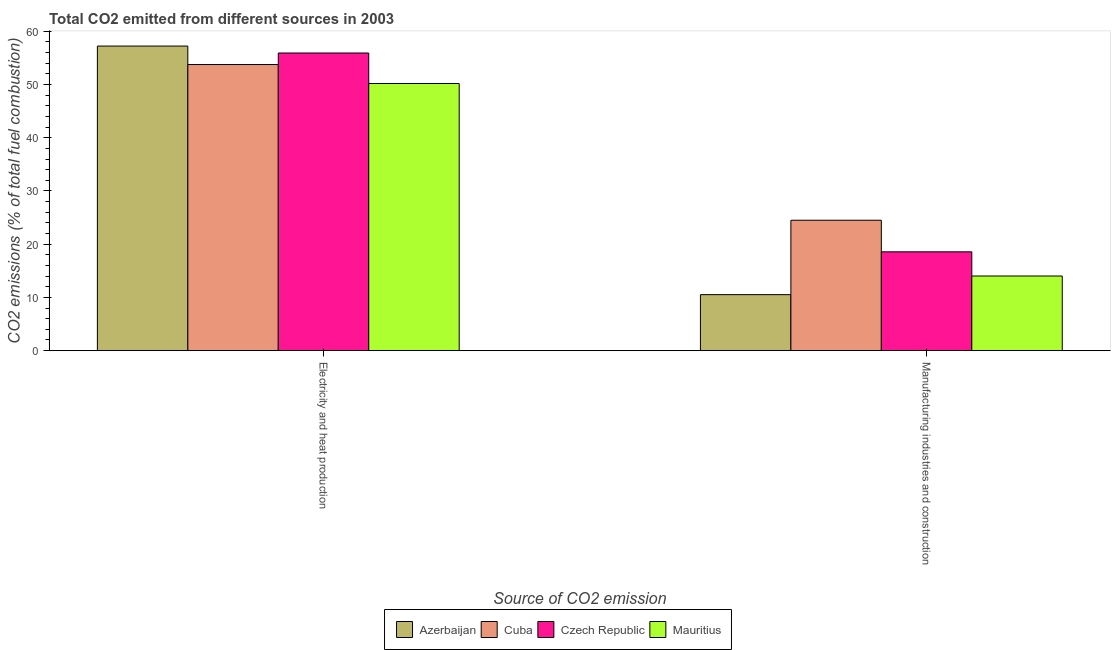Are the number of bars per tick equal to the number of legend labels?
Give a very brief answer. Yes. Are the number of bars on each tick of the X-axis equal?
Your answer should be compact. Yes. What is the label of the 1st group of bars from the left?
Your answer should be very brief. Electricity and heat production. What is the co2 emissions due to electricity and heat production in Azerbaijan?
Your response must be concise. 57.22. Across all countries, what is the maximum co2 emissions due to electricity and heat production?
Provide a short and direct response. 57.22. Across all countries, what is the minimum co2 emissions due to manufacturing industries?
Provide a succinct answer. 10.52. In which country was the co2 emissions due to manufacturing industries maximum?
Give a very brief answer. Cuba. In which country was the co2 emissions due to electricity and heat production minimum?
Give a very brief answer. Mauritius. What is the total co2 emissions due to manufacturing industries in the graph?
Offer a terse response. 67.6. What is the difference between the co2 emissions due to electricity and heat production in Azerbaijan and that in Mauritius?
Ensure brevity in your answer.  7.03. What is the difference between the co2 emissions due to manufacturing industries in Cuba and the co2 emissions due to electricity and heat production in Azerbaijan?
Make the answer very short. -32.72. What is the average co2 emissions due to electricity and heat production per country?
Provide a short and direct response. 54.27. What is the difference between the co2 emissions due to manufacturing industries and co2 emissions due to electricity and heat production in Czech Republic?
Keep it short and to the point. -37.35. In how many countries, is the co2 emissions due to manufacturing industries greater than 50 %?
Offer a terse response. 0. What is the ratio of the co2 emissions due to manufacturing industries in Cuba to that in Mauritius?
Your answer should be very brief. 1.75. In how many countries, is the co2 emissions due to electricity and heat production greater than the average co2 emissions due to electricity and heat production taken over all countries?
Keep it short and to the point. 2. What does the 2nd bar from the left in Manufacturing industries and construction represents?
Offer a terse response. Cuba. What does the 1st bar from the right in Manufacturing industries and construction represents?
Make the answer very short. Mauritius. How many bars are there?
Give a very brief answer. 8. How many countries are there in the graph?
Your answer should be compact. 4. What is the difference between two consecutive major ticks on the Y-axis?
Keep it short and to the point. 10. Are the values on the major ticks of Y-axis written in scientific E-notation?
Offer a terse response. No. Where does the legend appear in the graph?
Your answer should be compact. Bottom center. What is the title of the graph?
Provide a short and direct response. Total CO2 emitted from different sources in 2003. Does "Greece" appear as one of the legend labels in the graph?
Provide a short and direct response. No. What is the label or title of the X-axis?
Provide a succinct answer. Source of CO2 emission. What is the label or title of the Y-axis?
Provide a short and direct response. CO2 emissions (% of total fuel combustion). What is the CO2 emissions (% of total fuel combustion) in Azerbaijan in Electricity and heat production?
Give a very brief answer. 57.22. What is the CO2 emissions (% of total fuel combustion) in Cuba in Electricity and heat production?
Give a very brief answer. 53.75. What is the CO2 emissions (% of total fuel combustion) in Czech Republic in Electricity and heat production?
Make the answer very short. 55.91. What is the CO2 emissions (% of total fuel combustion) of Mauritius in Electricity and heat production?
Your answer should be very brief. 50.18. What is the CO2 emissions (% of total fuel combustion) in Azerbaijan in Manufacturing industries and construction?
Offer a very short reply. 10.52. What is the CO2 emissions (% of total fuel combustion) of Cuba in Manufacturing industries and construction?
Give a very brief answer. 24.5. What is the CO2 emissions (% of total fuel combustion) of Czech Republic in Manufacturing industries and construction?
Keep it short and to the point. 18.56. What is the CO2 emissions (% of total fuel combustion) of Mauritius in Manufacturing industries and construction?
Ensure brevity in your answer.  14.02. Across all Source of CO2 emission, what is the maximum CO2 emissions (% of total fuel combustion) in Azerbaijan?
Your answer should be compact. 57.22. Across all Source of CO2 emission, what is the maximum CO2 emissions (% of total fuel combustion) of Cuba?
Ensure brevity in your answer.  53.75. Across all Source of CO2 emission, what is the maximum CO2 emissions (% of total fuel combustion) of Czech Republic?
Make the answer very short. 55.91. Across all Source of CO2 emission, what is the maximum CO2 emissions (% of total fuel combustion) in Mauritius?
Provide a short and direct response. 50.18. Across all Source of CO2 emission, what is the minimum CO2 emissions (% of total fuel combustion) in Azerbaijan?
Give a very brief answer. 10.52. Across all Source of CO2 emission, what is the minimum CO2 emissions (% of total fuel combustion) in Cuba?
Your response must be concise. 24.5. Across all Source of CO2 emission, what is the minimum CO2 emissions (% of total fuel combustion) in Czech Republic?
Your response must be concise. 18.56. Across all Source of CO2 emission, what is the minimum CO2 emissions (% of total fuel combustion) of Mauritius?
Provide a succinct answer. 14.02. What is the total CO2 emissions (% of total fuel combustion) of Azerbaijan in the graph?
Your answer should be very brief. 67.74. What is the total CO2 emissions (% of total fuel combustion) in Cuba in the graph?
Offer a very short reply. 78.24. What is the total CO2 emissions (% of total fuel combustion) in Czech Republic in the graph?
Offer a terse response. 74.48. What is the total CO2 emissions (% of total fuel combustion) in Mauritius in the graph?
Keep it short and to the point. 64.21. What is the difference between the CO2 emissions (% of total fuel combustion) in Azerbaijan in Electricity and heat production and that in Manufacturing industries and construction?
Ensure brevity in your answer.  46.7. What is the difference between the CO2 emissions (% of total fuel combustion) in Cuba in Electricity and heat production and that in Manufacturing industries and construction?
Provide a succinct answer. 29.25. What is the difference between the CO2 emissions (% of total fuel combustion) of Czech Republic in Electricity and heat production and that in Manufacturing industries and construction?
Ensure brevity in your answer.  37.35. What is the difference between the CO2 emissions (% of total fuel combustion) in Mauritius in Electricity and heat production and that in Manufacturing industries and construction?
Offer a terse response. 36.16. What is the difference between the CO2 emissions (% of total fuel combustion) in Azerbaijan in Electricity and heat production and the CO2 emissions (% of total fuel combustion) in Cuba in Manufacturing industries and construction?
Provide a succinct answer. 32.72. What is the difference between the CO2 emissions (% of total fuel combustion) in Azerbaijan in Electricity and heat production and the CO2 emissions (% of total fuel combustion) in Czech Republic in Manufacturing industries and construction?
Offer a very short reply. 38.65. What is the difference between the CO2 emissions (% of total fuel combustion) in Azerbaijan in Electricity and heat production and the CO2 emissions (% of total fuel combustion) in Mauritius in Manufacturing industries and construction?
Your response must be concise. 43.2. What is the difference between the CO2 emissions (% of total fuel combustion) in Cuba in Electricity and heat production and the CO2 emissions (% of total fuel combustion) in Czech Republic in Manufacturing industries and construction?
Provide a short and direct response. 35.18. What is the difference between the CO2 emissions (% of total fuel combustion) of Cuba in Electricity and heat production and the CO2 emissions (% of total fuel combustion) of Mauritius in Manufacturing industries and construction?
Your answer should be compact. 39.72. What is the difference between the CO2 emissions (% of total fuel combustion) in Czech Republic in Electricity and heat production and the CO2 emissions (% of total fuel combustion) in Mauritius in Manufacturing industries and construction?
Your answer should be very brief. 41.89. What is the average CO2 emissions (% of total fuel combustion) in Azerbaijan per Source of CO2 emission?
Keep it short and to the point. 33.87. What is the average CO2 emissions (% of total fuel combustion) of Cuba per Source of CO2 emission?
Offer a terse response. 39.12. What is the average CO2 emissions (% of total fuel combustion) of Czech Republic per Source of CO2 emission?
Provide a short and direct response. 37.24. What is the average CO2 emissions (% of total fuel combustion) in Mauritius per Source of CO2 emission?
Your answer should be compact. 32.1. What is the difference between the CO2 emissions (% of total fuel combustion) of Azerbaijan and CO2 emissions (% of total fuel combustion) of Cuba in Electricity and heat production?
Provide a succinct answer. 3.47. What is the difference between the CO2 emissions (% of total fuel combustion) in Azerbaijan and CO2 emissions (% of total fuel combustion) in Czech Republic in Electricity and heat production?
Offer a very short reply. 1.3. What is the difference between the CO2 emissions (% of total fuel combustion) of Azerbaijan and CO2 emissions (% of total fuel combustion) of Mauritius in Electricity and heat production?
Keep it short and to the point. 7.03. What is the difference between the CO2 emissions (% of total fuel combustion) of Cuba and CO2 emissions (% of total fuel combustion) of Czech Republic in Electricity and heat production?
Make the answer very short. -2.17. What is the difference between the CO2 emissions (% of total fuel combustion) of Cuba and CO2 emissions (% of total fuel combustion) of Mauritius in Electricity and heat production?
Your answer should be compact. 3.56. What is the difference between the CO2 emissions (% of total fuel combustion) in Czech Republic and CO2 emissions (% of total fuel combustion) in Mauritius in Electricity and heat production?
Offer a very short reply. 5.73. What is the difference between the CO2 emissions (% of total fuel combustion) of Azerbaijan and CO2 emissions (% of total fuel combustion) of Cuba in Manufacturing industries and construction?
Your answer should be compact. -13.98. What is the difference between the CO2 emissions (% of total fuel combustion) of Azerbaijan and CO2 emissions (% of total fuel combustion) of Czech Republic in Manufacturing industries and construction?
Your answer should be very brief. -8.05. What is the difference between the CO2 emissions (% of total fuel combustion) of Azerbaijan and CO2 emissions (% of total fuel combustion) of Mauritius in Manufacturing industries and construction?
Your answer should be compact. -3.5. What is the difference between the CO2 emissions (% of total fuel combustion) in Cuba and CO2 emissions (% of total fuel combustion) in Czech Republic in Manufacturing industries and construction?
Give a very brief answer. 5.93. What is the difference between the CO2 emissions (% of total fuel combustion) of Cuba and CO2 emissions (% of total fuel combustion) of Mauritius in Manufacturing industries and construction?
Make the answer very short. 10.47. What is the difference between the CO2 emissions (% of total fuel combustion) of Czech Republic and CO2 emissions (% of total fuel combustion) of Mauritius in Manufacturing industries and construction?
Offer a terse response. 4.54. What is the ratio of the CO2 emissions (% of total fuel combustion) of Azerbaijan in Electricity and heat production to that in Manufacturing industries and construction?
Provide a succinct answer. 5.44. What is the ratio of the CO2 emissions (% of total fuel combustion) in Cuba in Electricity and heat production to that in Manufacturing industries and construction?
Provide a succinct answer. 2.19. What is the ratio of the CO2 emissions (% of total fuel combustion) in Czech Republic in Electricity and heat production to that in Manufacturing industries and construction?
Your answer should be very brief. 3.01. What is the ratio of the CO2 emissions (% of total fuel combustion) of Mauritius in Electricity and heat production to that in Manufacturing industries and construction?
Keep it short and to the point. 3.58. What is the difference between the highest and the second highest CO2 emissions (% of total fuel combustion) in Azerbaijan?
Your answer should be compact. 46.7. What is the difference between the highest and the second highest CO2 emissions (% of total fuel combustion) of Cuba?
Your response must be concise. 29.25. What is the difference between the highest and the second highest CO2 emissions (% of total fuel combustion) in Czech Republic?
Provide a succinct answer. 37.35. What is the difference between the highest and the second highest CO2 emissions (% of total fuel combustion) in Mauritius?
Provide a succinct answer. 36.16. What is the difference between the highest and the lowest CO2 emissions (% of total fuel combustion) in Azerbaijan?
Offer a terse response. 46.7. What is the difference between the highest and the lowest CO2 emissions (% of total fuel combustion) of Cuba?
Your answer should be compact. 29.25. What is the difference between the highest and the lowest CO2 emissions (% of total fuel combustion) in Czech Republic?
Your answer should be very brief. 37.35. What is the difference between the highest and the lowest CO2 emissions (% of total fuel combustion) of Mauritius?
Your answer should be compact. 36.16. 